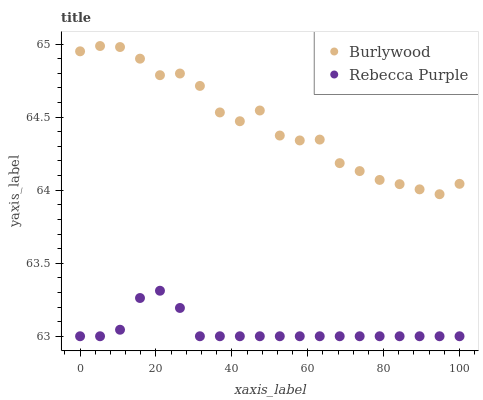Does Rebecca Purple have the minimum area under the curve?
Answer yes or no. Yes. Does Burlywood have the maximum area under the curve?
Answer yes or no. Yes. Does Rebecca Purple have the maximum area under the curve?
Answer yes or no. No. Is Rebecca Purple the smoothest?
Answer yes or no. Yes. Is Burlywood the roughest?
Answer yes or no. Yes. Is Rebecca Purple the roughest?
Answer yes or no. No. Does Rebecca Purple have the lowest value?
Answer yes or no. Yes. Does Burlywood have the highest value?
Answer yes or no. Yes. Does Rebecca Purple have the highest value?
Answer yes or no. No. Is Rebecca Purple less than Burlywood?
Answer yes or no. Yes. Is Burlywood greater than Rebecca Purple?
Answer yes or no. Yes. Does Rebecca Purple intersect Burlywood?
Answer yes or no. No. 